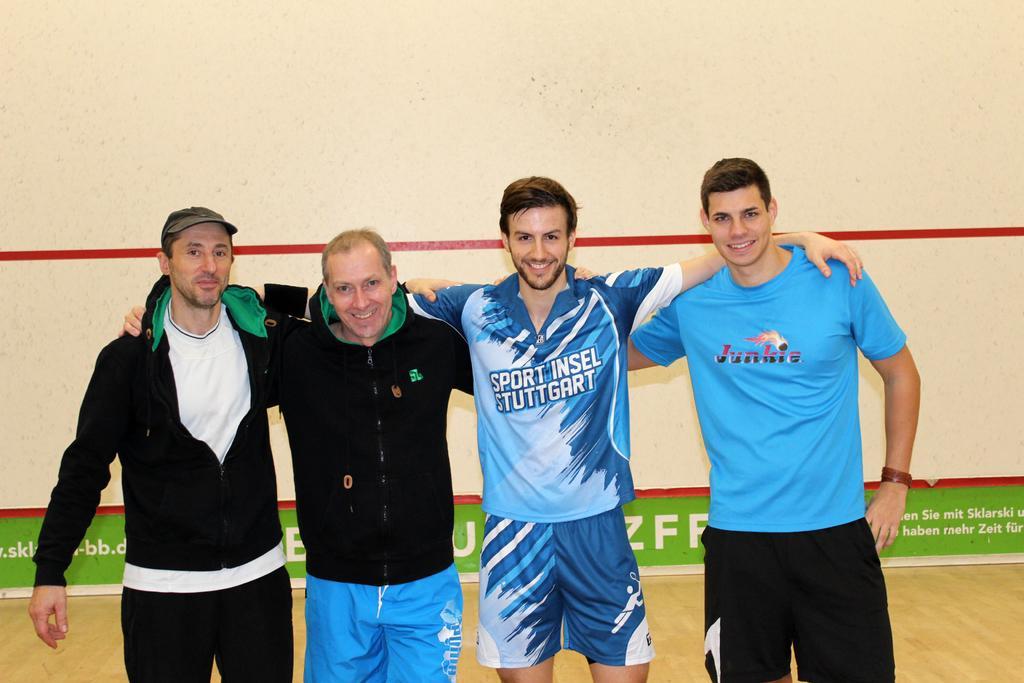Describe this image in one or two sentences. In this picture I can see 4 men who are standing in front and I see that they're smiling. In the background I can see the wall and I see the green color thing, on which there is something written. 